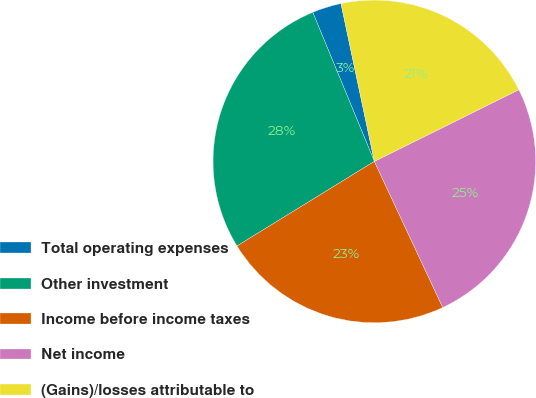<chart> <loc_0><loc_0><loc_500><loc_500><pie_chart><fcel>Total operating expenses<fcel>Other investment<fcel>Income before income taxes<fcel>Net income<fcel>(Gains)/losses attributable to<nl><fcel>2.92%<fcel>27.55%<fcel>23.18%<fcel>25.36%<fcel>20.99%<nl></chart> 